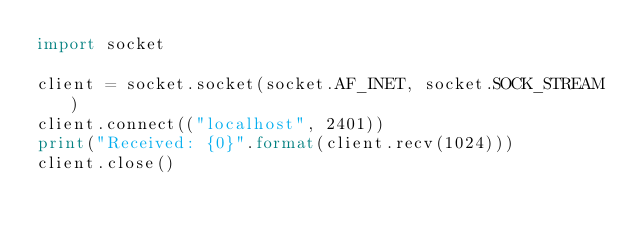<code> <loc_0><loc_0><loc_500><loc_500><_Python_>import socket

client = socket.socket(socket.AF_INET, socket.SOCK_STREAM)
client.connect(("localhost", 2401))
print("Received: {0}".format(client.recv(1024)))
client.close()
</code> 